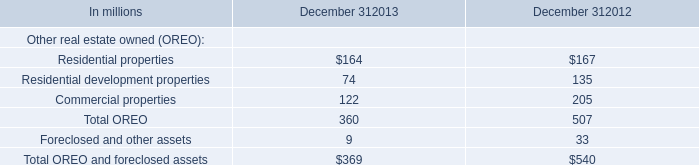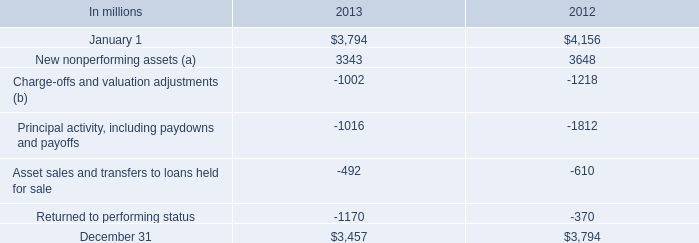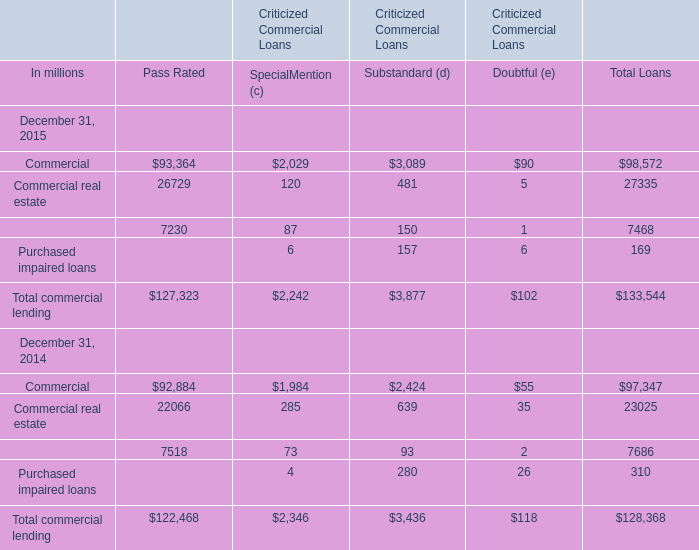at december 31 , 2015 what was the net change from december 31 , 2014 on alll on total purchased impaired loans in billions? 
Computations: (.3 - .9)
Answer: -0.6. 